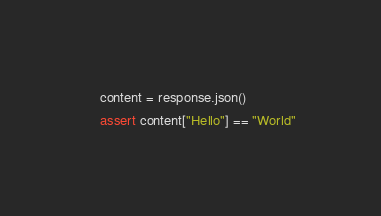Convert code to text. <code><loc_0><loc_0><loc_500><loc_500><_Python_>    content = response.json()
    assert content["Hello"] == "World"
</code> 